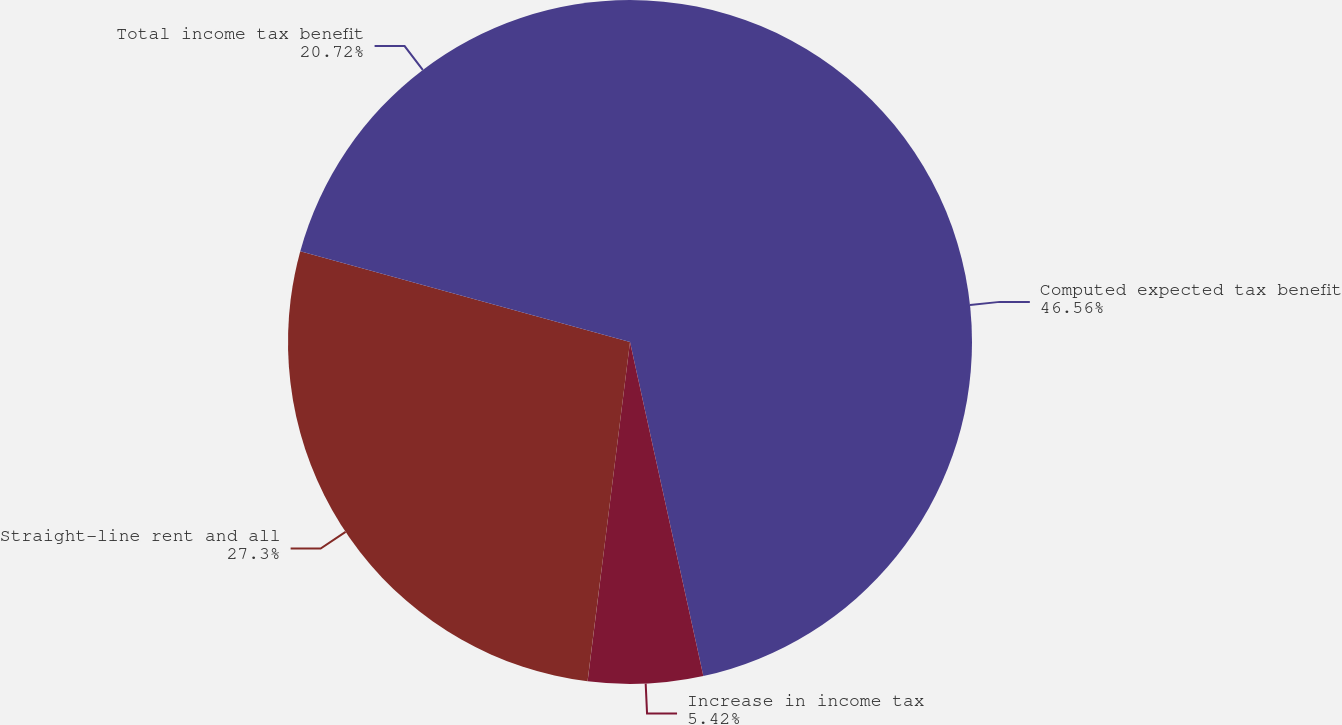Convert chart. <chart><loc_0><loc_0><loc_500><loc_500><pie_chart><fcel>Computed expected tax benefit<fcel>Increase in income tax<fcel>Straight-line rent and all<fcel>Total income tax benefit<nl><fcel>46.56%<fcel>5.42%<fcel>27.3%<fcel>20.72%<nl></chart> 